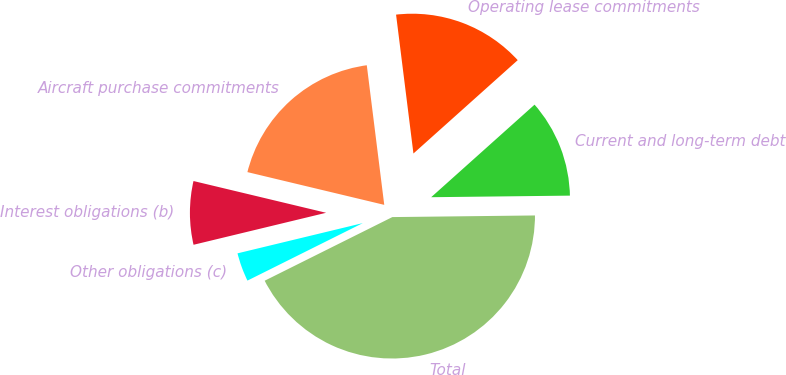<chart> <loc_0><loc_0><loc_500><loc_500><pie_chart><fcel>Current and long-term debt<fcel>Operating lease commitments<fcel>Aircraft purchase commitments<fcel>Interest obligations (b)<fcel>Other obligations (c)<fcel>Total<nl><fcel>11.44%<fcel>15.36%<fcel>19.28%<fcel>7.51%<fcel>3.59%<fcel>42.82%<nl></chart> 